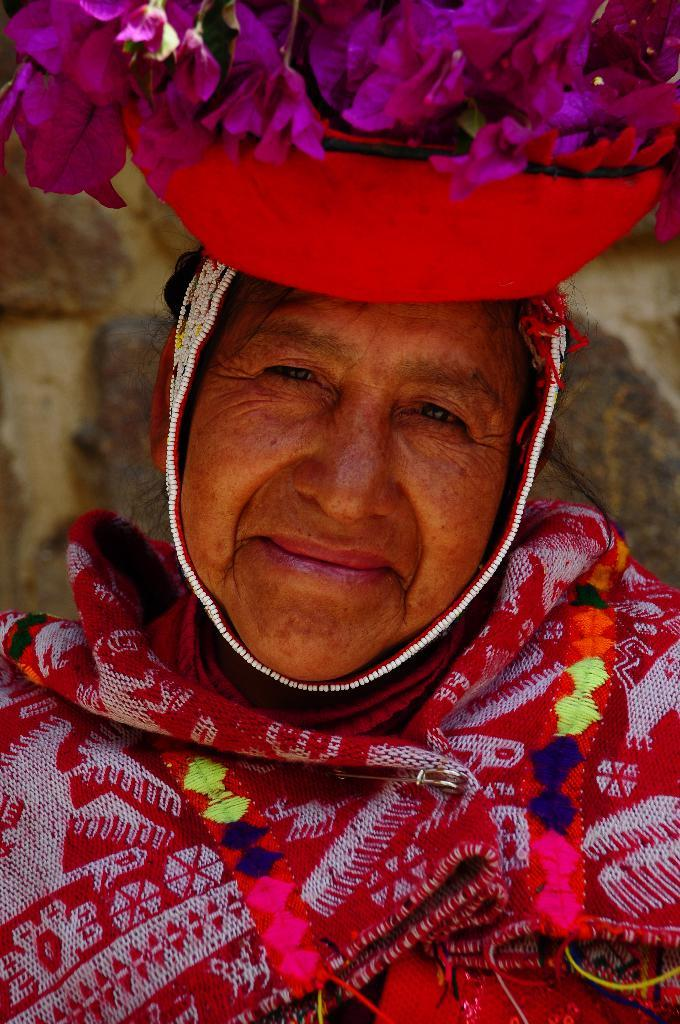Who is present in the image? There is a person in the image. What is the person wearing? The person is wearing a dress and a helmet. What is unique about the helmet? The helmet has flowers on it. What type of joke is being told in the image? There is no joke being told in the image; it features a person wearing a helmet with flowers on it. What valuable jewel can be seen in the person's hand in the image? There is no jewel visible in the person's hand or anywhere else in the image. 